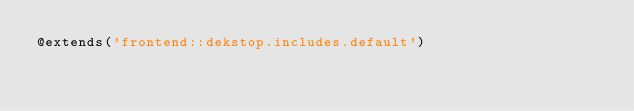Convert code to text. <code><loc_0><loc_0><loc_500><loc_500><_PHP_>@extends('frontend::dekstop.includes.default')</code> 